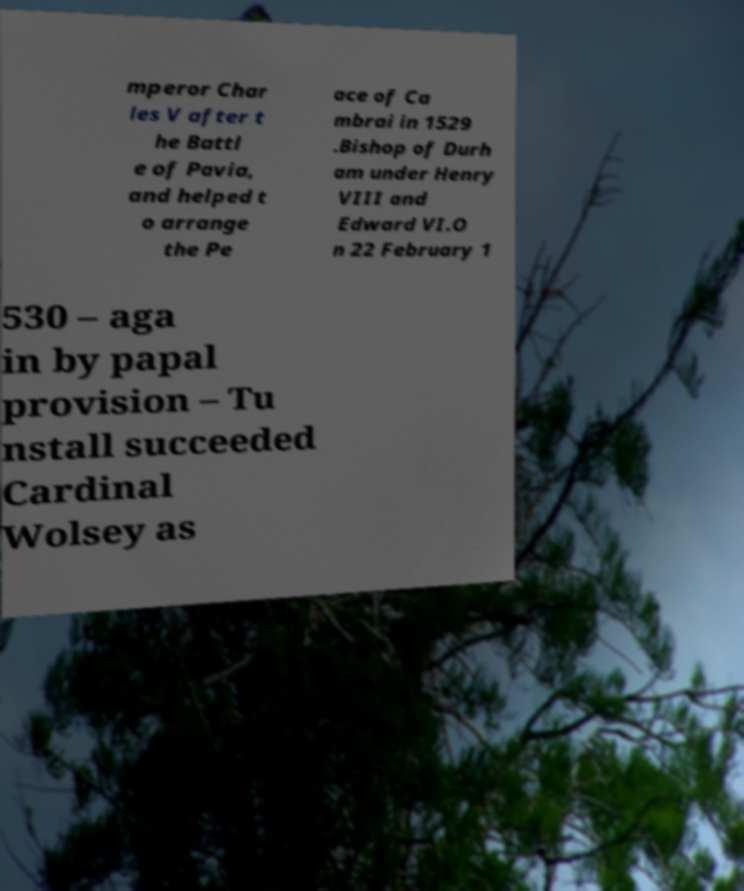I need the written content from this picture converted into text. Can you do that? mperor Char les V after t he Battl e of Pavia, and helped t o arrange the Pe ace of Ca mbrai in 1529 .Bishop of Durh am under Henry VIII and Edward VI.O n 22 February 1 530 – aga in by papal provision – Tu nstall succeeded Cardinal Wolsey as 